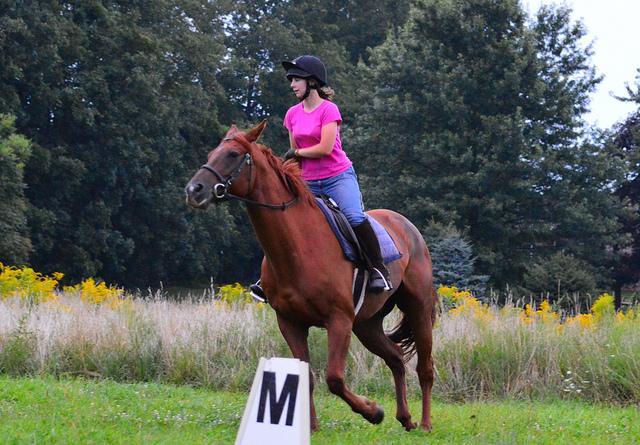What is the horse jumping?
Write a very short answer. Nothing. Where is the pink top?
Keep it brief. On woman. Is the horse running?
Be succinct. Yes. What color are the flowers in the background?
Keep it brief. Yellow. What color is his helmet?
Short answer required. Black. What letter is shown?
Give a very brief answer. M. 